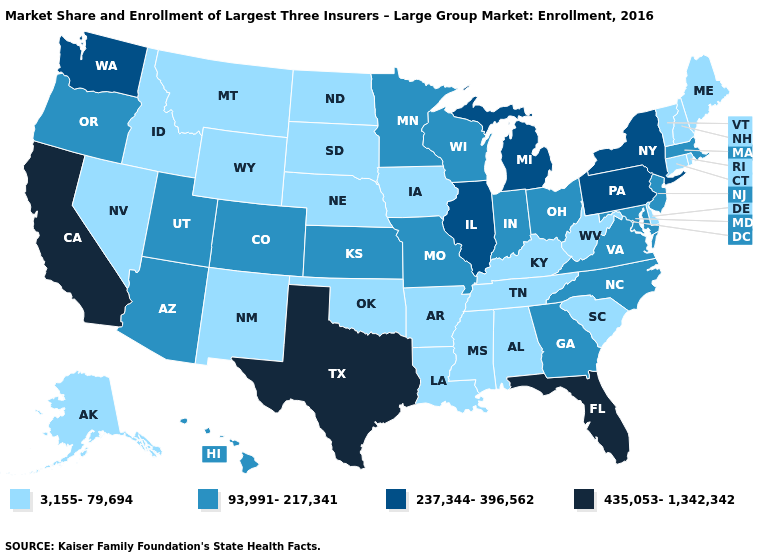Name the states that have a value in the range 3,155-79,694?
Answer briefly. Alabama, Alaska, Arkansas, Connecticut, Delaware, Idaho, Iowa, Kentucky, Louisiana, Maine, Mississippi, Montana, Nebraska, Nevada, New Hampshire, New Mexico, North Dakota, Oklahoma, Rhode Island, South Carolina, South Dakota, Tennessee, Vermont, West Virginia, Wyoming. Among the states that border Georgia , which have the lowest value?
Short answer required. Alabama, South Carolina, Tennessee. What is the lowest value in states that border Colorado?
Quick response, please. 3,155-79,694. Does Missouri have the lowest value in the USA?
Quick response, please. No. Does Arkansas have a lower value than Kansas?
Concise answer only. Yes. Is the legend a continuous bar?
Answer briefly. No. What is the lowest value in states that border California?
Be succinct. 3,155-79,694. Among the states that border West Virginia , does Kentucky have the highest value?
Answer briefly. No. Does Texas have the highest value in the South?
Be succinct. Yes. Does California have the highest value in the USA?
Quick response, please. Yes. Name the states that have a value in the range 237,344-396,562?
Quick response, please. Illinois, Michigan, New York, Pennsylvania, Washington. Name the states that have a value in the range 3,155-79,694?
Give a very brief answer. Alabama, Alaska, Arkansas, Connecticut, Delaware, Idaho, Iowa, Kentucky, Louisiana, Maine, Mississippi, Montana, Nebraska, Nevada, New Hampshire, New Mexico, North Dakota, Oklahoma, Rhode Island, South Carolina, South Dakota, Tennessee, Vermont, West Virginia, Wyoming. What is the value of Wyoming?
Answer briefly. 3,155-79,694. Which states have the lowest value in the USA?
Write a very short answer. Alabama, Alaska, Arkansas, Connecticut, Delaware, Idaho, Iowa, Kentucky, Louisiana, Maine, Mississippi, Montana, Nebraska, Nevada, New Hampshire, New Mexico, North Dakota, Oklahoma, Rhode Island, South Carolina, South Dakota, Tennessee, Vermont, West Virginia, Wyoming. Which states hav the highest value in the MidWest?
Concise answer only. Illinois, Michigan. 